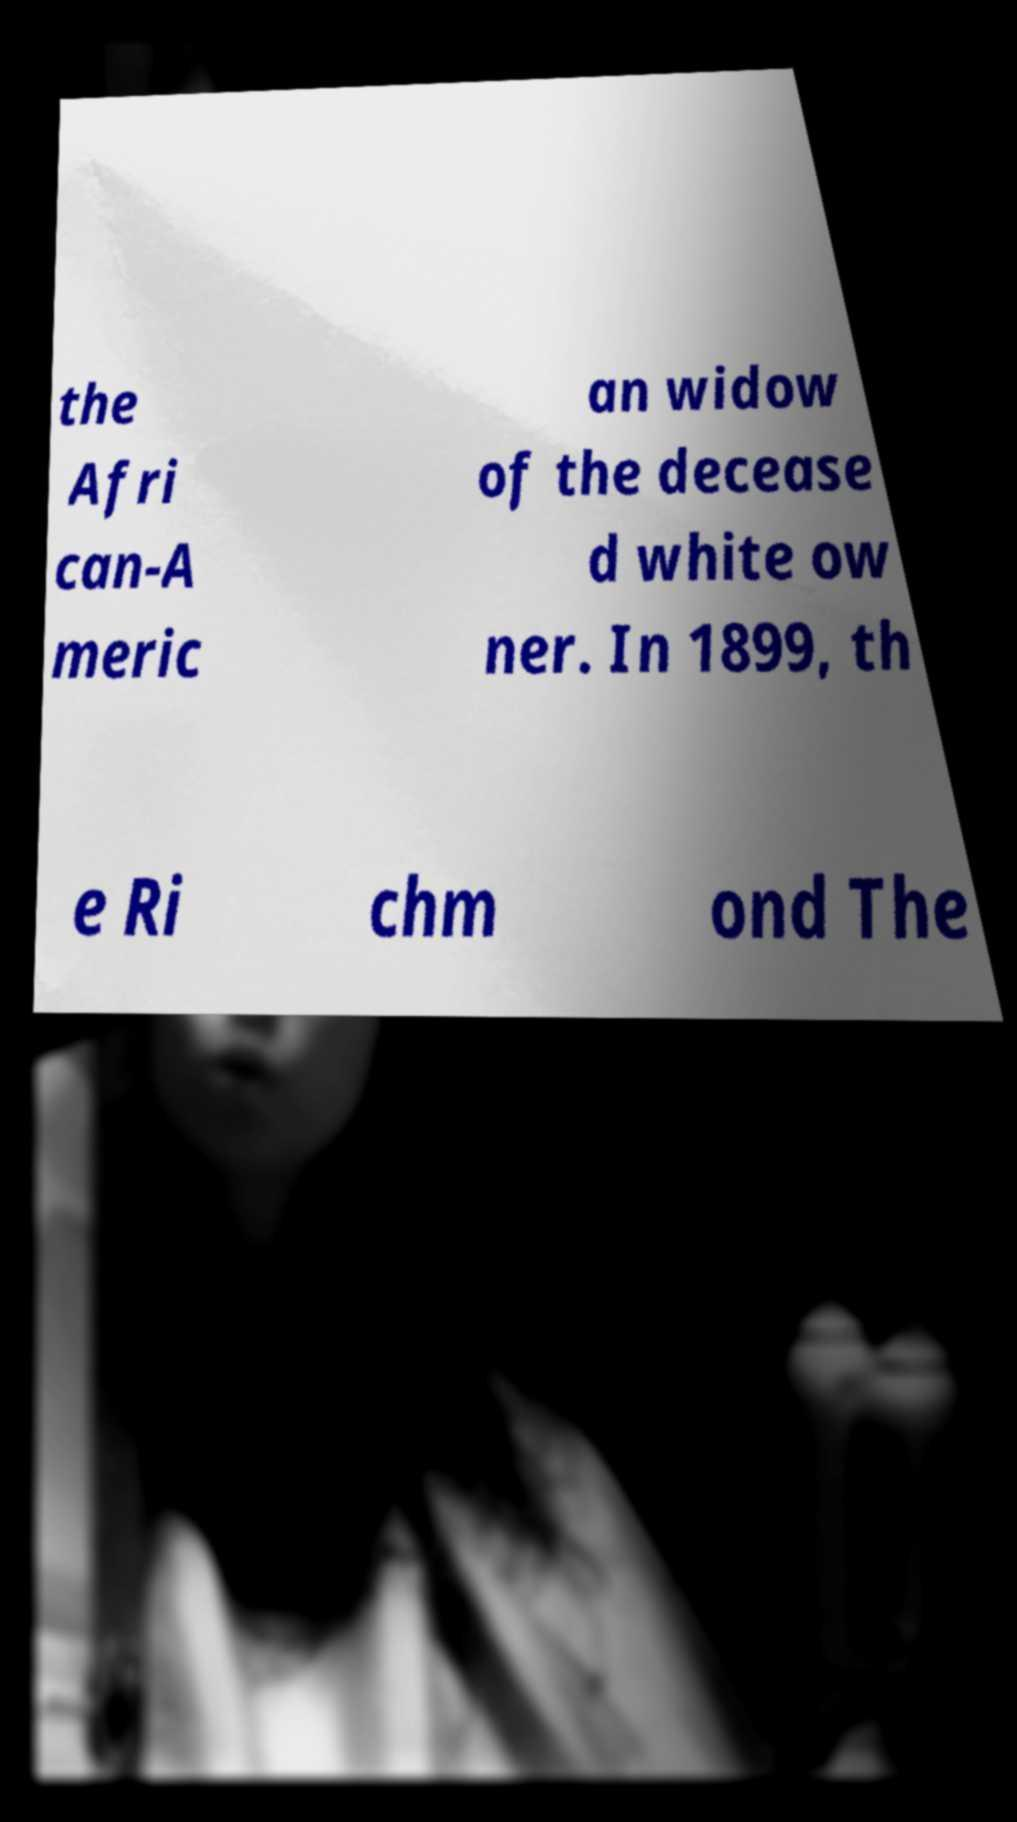Could you extract and type out the text from this image? the Afri can-A meric an widow of the decease d white ow ner. In 1899, th e Ri chm ond The 